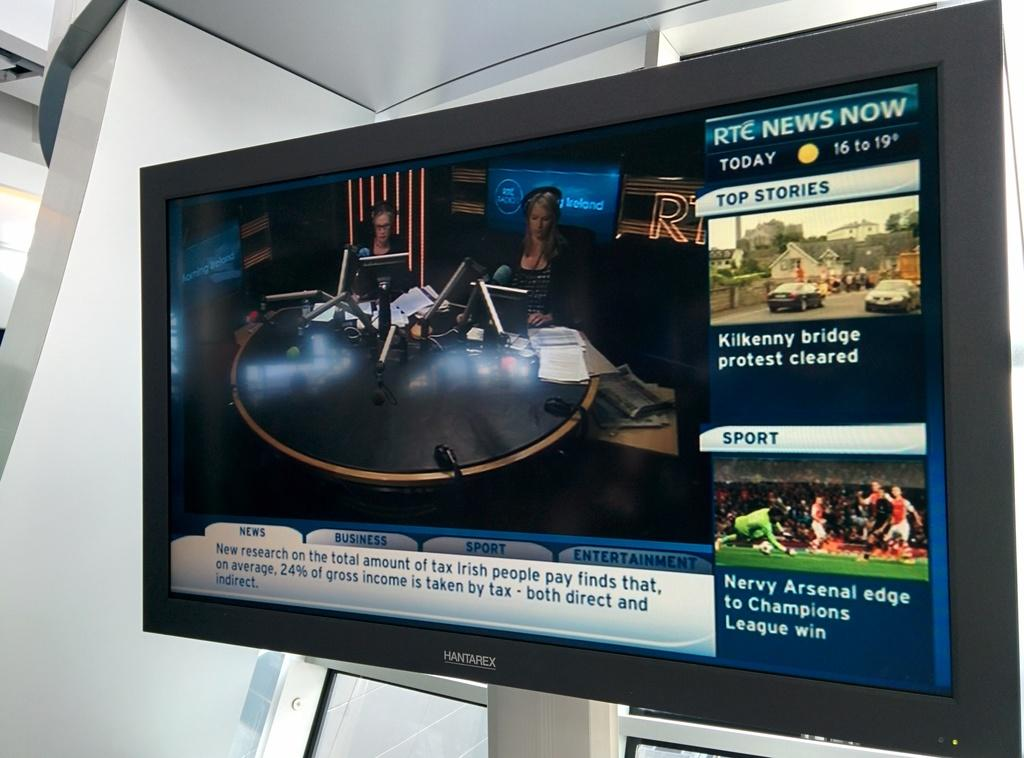<image>
Summarize the visual content of the image. A Hantarex television shows the RTE News now. 